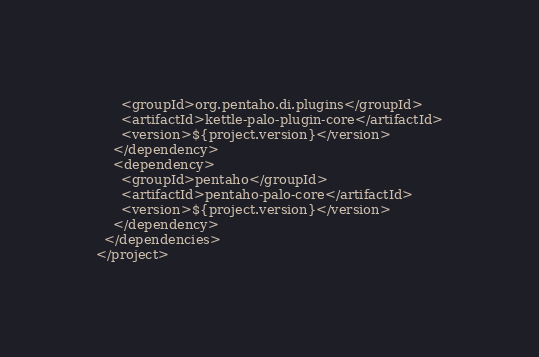Convert code to text. <code><loc_0><loc_0><loc_500><loc_500><_XML_>      <groupId>org.pentaho.di.plugins</groupId>
      <artifactId>kettle-palo-plugin-core</artifactId>
      <version>${project.version}</version>
    </dependency>
    <dependency>
      <groupId>pentaho</groupId>
      <artifactId>pentaho-palo-core</artifactId>
      <version>${project.version}</version>
    </dependency>
  </dependencies>
</project>
</code> 